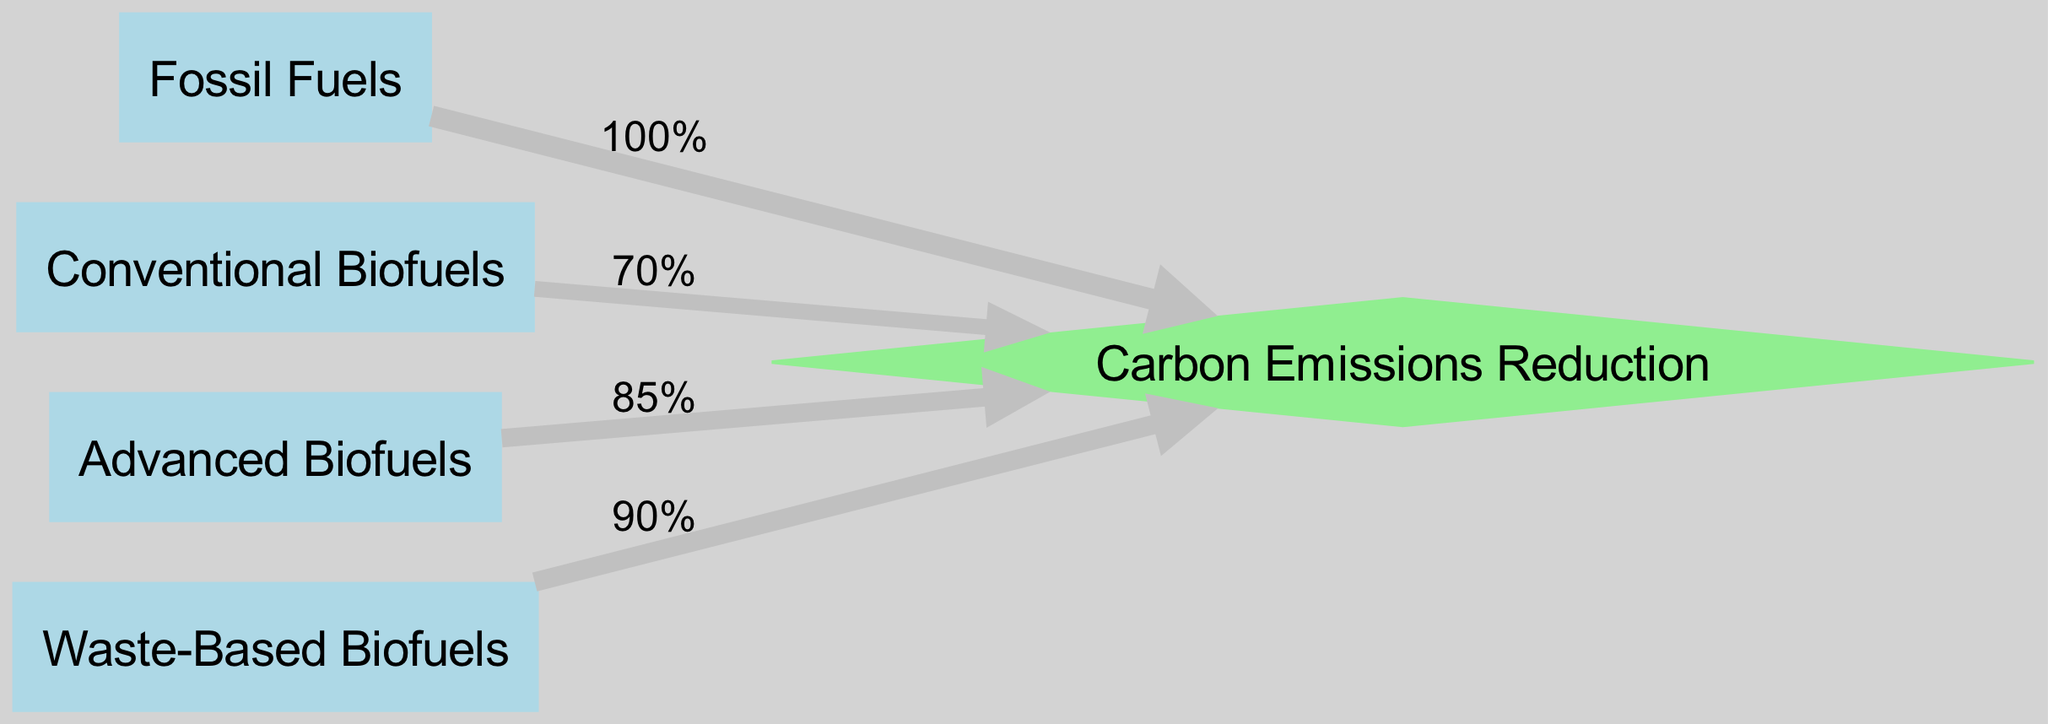What is the carbon emissions reduction from Fossil Fuels? The link from the "Fossil Fuels" node to the "Carbon Emissions Reduction" node shows a value of 100%.
Answer: 100% How many types of biofuels are shown in the diagram? There are three types of biofuels in the diagram: Conventional Biofuels, Advanced Biofuels, and Waste-Based Biofuels.
Answer: 3 Which biofuel has the highest emissions reduction? Comparing the links for each biofuel leading to "Carbon Emissions Reduction," Advanced Biofuels has the highest value of 85%.
Answer: Advanced Biofuels What percentage of carbon emissions reduction do Conventional Biofuels provide compared to Waste-Based Biofuels? Conventional Biofuels offer 70% reduction while Waste-Based Biofuels offer 90%. Therefore, Waste-Based Biofuels provide 20% more reduction than Conventional Biofuels (90% - 70% = 20%).
Answer: 20% What is the total carbon emissions reduction from all biofuels combined? To find the total, add the reductions from all biofuels: 70% (Conventional) + 85% (Advanced) + 90% (Waste-Based) = 245%.
Answer: 245% How does Advanced Biofuels compare to Fossil Fuels in emissions reduction? Advanced Biofuels provide an 85% reduction while Fossil Fuels contribute 100%. This indicates that Fossil Fuels have 15% more emissions than Advanced Biofuels.
Answer: 15% Which node has the largest link width? The link from "Fossil Fuels" to "Carbon Emissions Reduction" has the maximum value of 100%, thus resulting in the largest link width.
Answer: Fossil Fuels What is the total number of links in the diagram? The diagram has four links, connecting each biofuel type to the carbon emissions reduction sink.
Answer: 4 